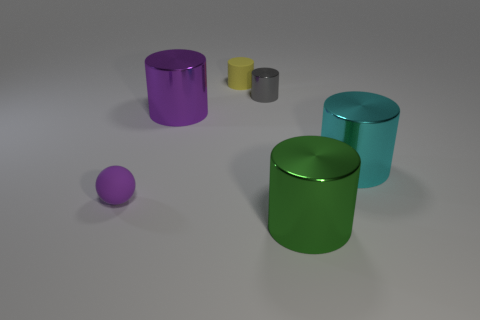Subtract all big purple shiny cylinders. How many cylinders are left? 4 Subtract all cyan cylinders. How many cylinders are left? 4 Subtract 1 cylinders. How many cylinders are left? 4 Add 3 spheres. How many objects exist? 9 Subtract all cyan cylinders. Subtract all purple cubes. How many cylinders are left? 4 Subtract all spheres. How many objects are left? 5 Subtract all large green shiny cylinders. Subtract all matte cylinders. How many objects are left? 4 Add 5 purple matte objects. How many purple matte objects are left? 6 Add 1 blue shiny balls. How many blue shiny balls exist? 1 Subtract 0 cyan blocks. How many objects are left? 6 